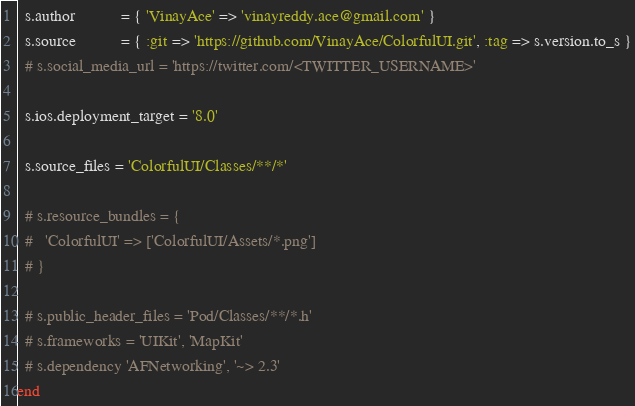<code> <loc_0><loc_0><loc_500><loc_500><_Ruby_>  s.author           = { 'VinayAce' => 'vinayreddy.ace@gmail.com' }
  s.source           = { :git => 'https://github.com/VinayAce/ColorfulUI.git', :tag => s.version.to_s }
  # s.social_media_url = 'https://twitter.com/<TWITTER_USERNAME>'

  s.ios.deployment_target = '8.0'

  s.source_files = 'ColorfulUI/Classes/**/*'
  
  # s.resource_bundles = {
  #   'ColorfulUI' => ['ColorfulUI/Assets/*.png']
  # }

  # s.public_header_files = 'Pod/Classes/**/*.h'
  # s.frameworks = 'UIKit', 'MapKit'
  # s.dependency 'AFNetworking', '~> 2.3'
end
</code> 